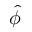<formula> <loc_0><loc_0><loc_500><loc_500>\hat { \phi }</formula> 